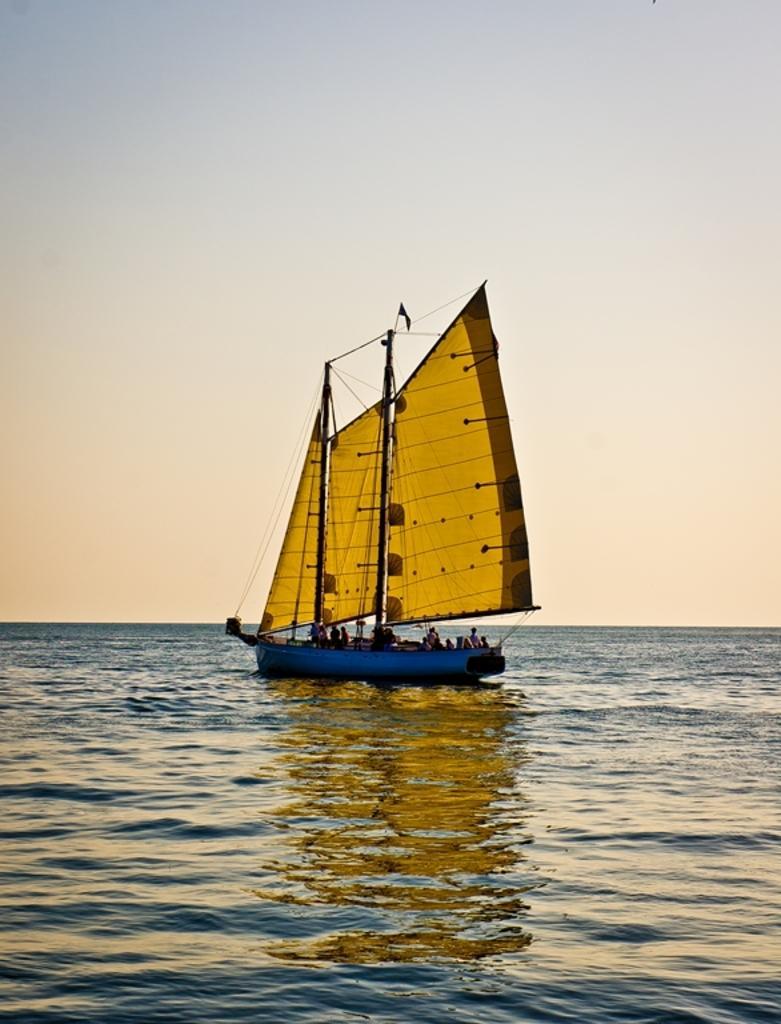Could you give a brief overview of what you see in this image? As we can see in the image there are few people on boats. There is water and sky. 